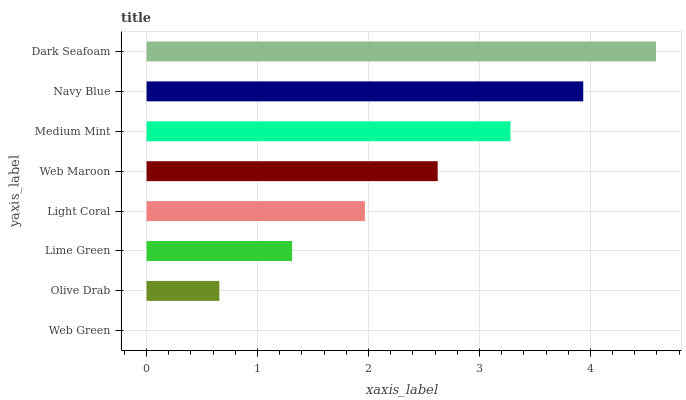Is Web Green the minimum?
Answer yes or no. Yes. Is Dark Seafoam the maximum?
Answer yes or no. Yes. Is Olive Drab the minimum?
Answer yes or no. No. Is Olive Drab the maximum?
Answer yes or no. No. Is Olive Drab greater than Web Green?
Answer yes or no. Yes. Is Web Green less than Olive Drab?
Answer yes or no. Yes. Is Web Green greater than Olive Drab?
Answer yes or no. No. Is Olive Drab less than Web Green?
Answer yes or no. No. Is Web Maroon the high median?
Answer yes or no. Yes. Is Light Coral the low median?
Answer yes or no. Yes. Is Dark Seafoam the high median?
Answer yes or no. No. Is Olive Drab the low median?
Answer yes or no. No. 